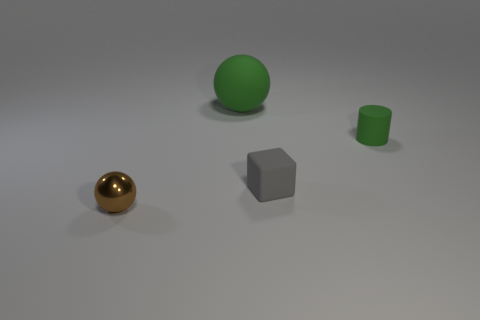Add 4 tiny things. How many objects exist? 8 Subtract all cylinders. How many objects are left? 3 Add 2 big rubber objects. How many big rubber objects exist? 3 Subtract 0 gray cylinders. How many objects are left? 4 Subtract all tiny red matte objects. Subtract all gray rubber things. How many objects are left? 3 Add 3 small cylinders. How many small cylinders are left? 4 